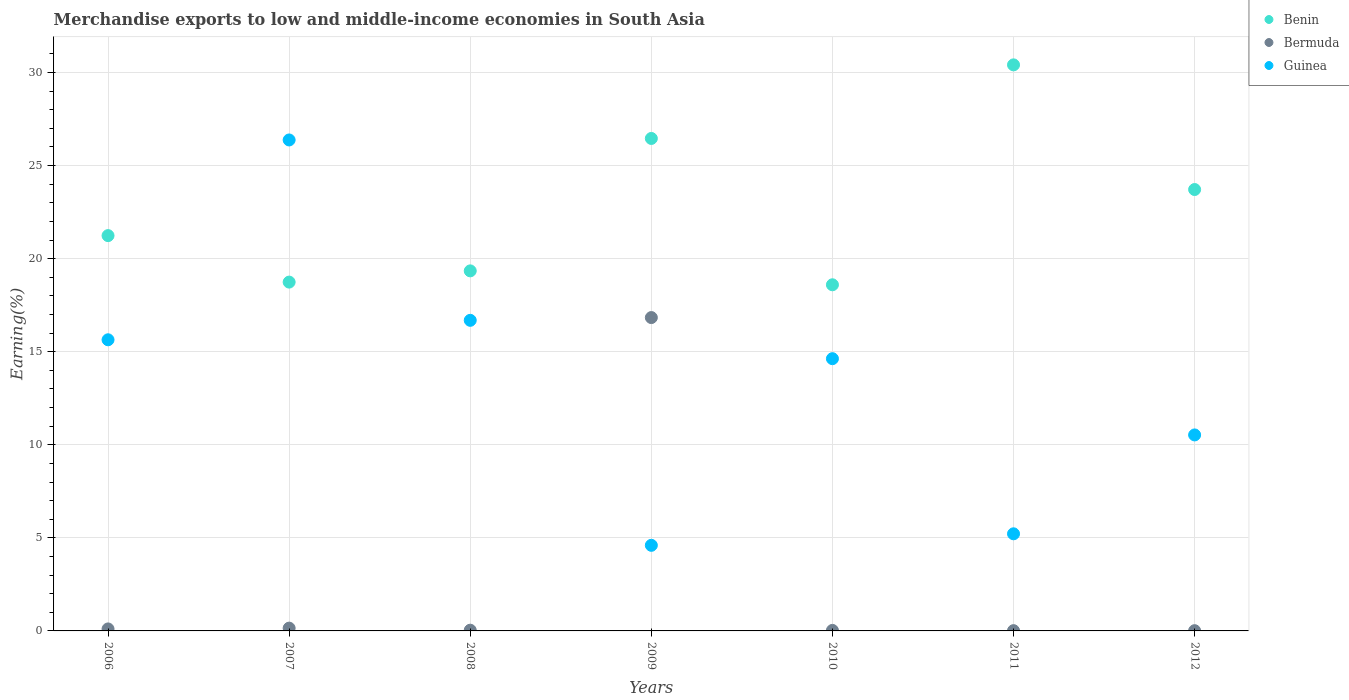Is the number of dotlines equal to the number of legend labels?
Provide a succinct answer. Yes. What is the percentage of amount earned from merchandise exports in Bermuda in 2008?
Offer a terse response. 0.04. Across all years, what is the maximum percentage of amount earned from merchandise exports in Guinea?
Make the answer very short. 26.37. Across all years, what is the minimum percentage of amount earned from merchandise exports in Bermuda?
Provide a succinct answer. 0.01. In which year was the percentage of amount earned from merchandise exports in Guinea maximum?
Provide a succinct answer. 2007. In which year was the percentage of amount earned from merchandise exports in Bermuda minimum?
Your response must be concise. 2012. What is the total percentage of amount earned from merchandise exports in Bermuda in the graph?
Ensure brevity in your answer.  17.18. What is the difference between the percentage of amount earned from merchandise exports in Bermuda in 2006 and that in 2009?
Keep it short and to the point. -16.73. What is the difference between the percentage of amount earned from merchandise exports in Bermuda in 2012 and the percentage of amount earned from merchandise exports in Guinea in 2010?
Ensure brevity in your answer.  -14.61. What is the average percentage of amount earned from merchandise exports in Guinea per year?
Your answer should be compact. 13.38. In the year 2012, what is the difference between the percentage of amount earned from merchandise exports in Guinea and percentage of amount earned from merchandise exports in Benin?
Keep it short and to the point. -13.18. What is the ratio of the percentage of amount earned from merchandise exports in Benin in 2008 to that in 2011?
Ensure brevity in your answer.  0.64. Is the difference between the percentage of amount earned from merchandise exports in Guinea in 2006 and 2007 greater than the difference between the percentage of amount earned from merchandise exports in Benin in 2006 and 2007?
Offer a very short reply. No. What is the difference between the highest and the second highest percentage of amount earned from merchandise exports in Benin?
Your response must be concise. 3.95. What is the difference between the highest and the lowest percentage of amount earned from merchandise exports in Bermuda?
Offer a terse response. 16.82. In how many years, is the percentage of amount earned from merchandise exports in Bermuda greater than the average percentage of amount earned from merchandise exports in Bermuda taken over all years?
Your answer should be compact. 1. Is the sum of the percentage of amount earned from merchandise exports in Benin in 2009 and 2012 greater than the maximum percentage of amount earned from merchandise exports in Guinea across all years?
Offer a very short reply. Yes. Is the percentage of amount earned from merchandise exports in Benin strictly less than the percentage of amount earned from merchandise exports in Bermuda over the years?
Keep it short and to the point. No. How many years are there in the graph?
Offer a terse response. 7. What is the difference between two consecutive major ticks on the Y-axis?
Offer a terse response. 5. Does the graph contain any zero values?
Your response must be concise. No. What is the title of the graph?
Ensure brevity in your answer.  Merchandise exports to low and middle-income economies in South Asia. What is the label or title of the X-axis?
Ensure brevity in your answer.  Years. What is the label or title of the Y-axis?
Your answer should be compact. Earning(%). What is the Earning(%) in Benin in 2006?
Keep it short and to the point. 21.24. What is the Earning(%) in Bermuda in 2006?
Provide a short and direct response. 0.11. What is the Earning(%) in Guinea in 2006?
Ensure brevity in your answer.  15.64. What is the Earning(%) in Benin in 2007?
Ensure brevity in your answer.  18.74. What is the Earning(%) in Bermuda in 2007?
Your answer should be compact. 0.15. What is the Earning(%) of Guinea in 2007?
Give a very brief answer. 26.37. What is the Earning(%) of Benin in 2008?
Offer a very short reply. 19.34. What is the Earning(%) in Bermuda in 2008?
Make the answer very short. 0.04. What is the Earning(%) of Guinea in 2008?
Your answer should be very brief. 16.69. What is the Earning(%) in Benin in 2009?
Provide a short and direct response. 26.46. What is the Earning(%) of Bermuda in 2009?
Your response must be concise. 16.83. What is the Earning(%) of Guinea in 2009?
Provide a succinct answer. 4.6. What is the Earning(%) in Benin in 2010?
Give a very brief answer. 18.59. What is the Earning(%) in Bermuda in 2010?
Provide a short and direct response. 0.03. What is the Earning(%) of Guinea in 2010?
Make the answer very short. 14.62. What is the Earning(%) in Benin in 2011?
Keep it short and to the point. 30.41. What is the Earning(%) of Bermuda in 2011?
Make the answer very short. 0.01. What is the Earning(%) in Guinea in 2011?
Make the answer very short. 5.22. What is the Earning(%) of Benin in 2012?
Keep it short and to the point. 23.71. What is the Earning(%) of Bermuda in 2012?
Your answer should be very brief. 0.01. What is the Earning(%) in Guinea in 2012?
Keep it short and to the point. 10.53. Across all years, what is the maximum Earning(%) of Benin?
Make the answer very short. 30.41. Across all years, what is the maximum Earning(%) of Bermuda?
Your answer should be compact. 16.83. Across all years, what is the maximum Earning(%) of Guinea?
Provide a short and direct response. 26.37. Across all years, what is the minimum Earning(%) in Benin?
Provide a succinct answer. 18.59. Across all years, what is the minimum Earning(%) in Bermuda?
Your answer should be compact. 0.01. Across all years, what is the minimum Earning(%) of Guinea?
Your answer should be compact. 4.6. What is the total Earning(%) of Benin in the graph?
Give a very brief answer. 158.49. What is the total Earning(%) in Bermuda in the graph?
Your answer should be compact. 17.18. What is the total Earning(%) in Guinea in the graph?
Keep it short and to the point. 93.67. What is the difference between the Earning(%) of Benin in 2006 and that in 2007?
Provide a short and direct response. 2.5. What is the difference between the Earning(%) of Bermuda in 2006 and that in 2007?
Your answer should be compact. -0.04. What is the difference between the Earning(%) of Guinea in 2006 and that in 2007?
Give a very brief answer. -10.73. What is the difference between the Earning(%) of Benin in 2006 and that in 2008?
Ensure brevity in your answer.  1.89. What is the difference between the Earning(%) in Bermuda in 2006 and that in 2008?
Ensure brevity in your answer.  0.07. What is the difference between the Earning(%) of Guinea in 2006 and that in 2008?
Your answer should be very brief. -1.05. What is the difference between the Earning(%) in Benin in 2006 and that in 2009?
Your response must be concise. -5.22. What is the difference between the Earning(%) in Bermuda in 2006 and that in 2009?
Offer a very short reply. -16.73. What is the difference between the Earning(%) in Guinea in 2006 and that in 2009?
Make the answer very short. 11.04. What is the difference between the Earning(%) of Benin in 2006 and that in 2010?
Provide a short and direct response. 2.64. What is the difference between the Earning(%) in Bermuda in 2006 and that in 2010?
Offer a very short reply. 0.08. What is the difference between the Earning(%) of Benin in 2006 and that in 2011?
Provide a succinct answer. -9.17. What is the difference between the Earning(%) in Bermuda in 2006 and that in 2011?
Provide a short and direct response. 0.09. What is the difference between the Earning(%) in Guinea in 2006 and that in 2011?
Offer a very short reply. 10.42. What is the difference between the Earning(%) in Benin in 2006 and that in 2012?
Your answer should be compact. -2.48. What is the difference between the Earning(%) of Bermuda in 2006 and that in 2012?
Your answer should be compact. 0.09. What is the difference between the Earning(%) of Guinea in 2006 and that in 2012?
Ensure brevity in your answer.  5.11. What is the difference between the Earning(%) in Benin in 2007 and that in 2008?
Your answer should be very brief. -0.6. What is the difference between the Earning(%) in Bermuda in 2007 and that in 2008?
Offer a very short reply. 0.11. What is the difference between the Earning(%) in Guinea in 2007 and that in 2008?
Offer a very short reply. 9.69. What is the difference between the Earning(%) in Benin in 2007 and that in 2009?
Offer a very short reply. -7.72. What is the difference between the Earning(%) of Bermuda in 2007 and that in 2009?
Provide a succinct answer. -16.68. What is the difference between the Earning(%) in Guinea in 2007 and that in 2009?
Provide a succinct answer. 21.78. What is the difference between the Earning(%) of Benin in 2007 and that in 2010?
Keep it short and to the point. 0.14. What is the difference between the Earning(%) of Bermuda in 2007 and that in 2010?
Offer a very short reply. 0.12. What is the difference between the Earning(%) in Guinea in 2007 and that in 2010?
Give a very brief answer. 11.75. What is the difference between the Earning(%) of Benin in 2007 and that in 2011?
Make the answer very short. -11.67. What is the difference between the Earning(%) in Bermuda in 2007 and that in 2011?
Give a very brief answer. 0.14. What is the difference between the Earning(%) of Guinea in 2007 and that in 2011?
Give a very brief answer. 21.16. What is the difference between the Earning(%) in Benin in 2007 and that in 2012?
Ensure brevity in your answer.  -4.97. What is the difference between the Earning(%) in Bermuda in 2007 and that in 2012?
Offer a very short reply. 0.14. What is the difference between the Earning(%) of Guinea in 2007 and that in 2012?
Give a very brief answer. 15.85. What is the difference between the Earning(%) in Benin in 2008 and that in 2009?
Provide a succinct answer. -7.11. What is the difference between the Earning(%) of Bermuda in 2008 and that in 2009?
Give a very brief answer. -16.79. What is the difference between the Earning(%) in Guinea in 2008 and that in 2009?
Offer a terse response. 12.09. What is the difference between the Earning(%) in Benin in 2008 and that in 2010?
Ensure brevity in your answer.  0.75. What is the difference between the Earning(%) in Bermuda in 2008 and that in 2010?
Offer a terse response. 0.01. What is the difference between the Earning(%) in Guinea in 2008 and that in 2010?
Make the answer very short. 2.06. What is the difference between the Earning(%) in Benin in 2008 and that in 2011?
Make the answer very short. -11.07. What is the difference between the Earning(%) in Bermuda in 2008 and that in 2011?
Provide a short and direct response. 0.02. What is the difference between the Earning(%) of Guinea in 2008 and that in 2011?
Your answer should be very brief. 11.47. What is the difference between the Earning(%) of Benin in 2008 and that in 2012?
Make the answer very short. -4.37. What is the difference between the Earning(%) of Bermuda in 2008 and that in 2012?
Your answer should be compact. 0.03. What is the difference between the Earning(%) of Guinea in 2008 and that in 2012?
Provide a succinct answer. 6.16. What is the difference between the Earning(%) in Benin in 2009 and that in 2010?
Your response must be concise. 7.86. What is the difference between the Earning(%) of Bermuda in 2009 and that in 2010?
Give a very brief answer. 16.81. What is the difference between the Earning(%) of Guinea in 2009 and that in 2010?
Your answer should be very brief. -10.03. What is the difference between the Earning(%) of Benin in 2009 and that in 2011?
Ensure brevity in your answer.  -3.95. What is the difference between the Earning(%) of Bermuda in 2009 and that in 2011?
Give a very brief answer. 16.82. What is the difference between the Earning(%) in Guinea in 2009 and that in 2011?
Provide a succinct answer. -0.62. What is the difference between the Earning(%) in Benin in 2009 and that in 2012?
Keep it short and to the point. 2.74. What is the difference between the Earning(%) in Bermuda in 2009 and that in 2012?
Make the answer very short. 16.82. What is the difference between the Earning(%) in Guinea in 2009 and that in 2012?
Provide a short and direct response. -5.93. What is the difference between the Earning(%) in Benin in 2010 and that in 2011?
Offer a very short reply. -11.81. What is the difference between the Earning(%) in Bermuda in 2010 and that in 2011?
Make the answer very short. 0.01. What is the difference between the Earning(%) in Guinea in 2010 and that in 2011?
Ensure brevity in your answer.  9.41. What is the difference between the Earning(%) in Benin in 2010 and that in 2012?
Offer a very short reply. -5.12. What is the difference between the Earning(%) in Bermuda in 2010 and that in 2012?
Make the answer very short. 0.01. What is the difference between the Earning(%) in Guinea in 2010 and that in 2012?
Ensure brevity in your answer.  4.1. What is the difference between the Earning(%) of Benin in 2011 and that in 2012?
Give a very brief answer. 6.7. What is the difference between the Earning(%) of Bermuda in 2011 and that in 2012?
Provide a short and direct response. 0. What is the difference between the Earning(%) in Guinea in 2011 and that in 2012?
Keep it short and to the point. -5.31. What is the difference between the Earning(%) of Benin in 2006 and the Earning(%) of Bermuda in 2007?
Your answer should be compact. 21.09. What is the difference between the Earning(%) of Benin in 2006 and the Earning(%) of Guinea in 2007?
Keep it short and to the point. -5.14. What is the difference between the Earning(%) of Bermuda in 2006 and the Earning(%) of Guinea in 2007?
Offer a terse response. -26.27. What is the difference between the Earning(%) in Benin in 2006 and the Earning(%) in Bermuda in 2008?
Offer a terse response. 21.2. What is the difference between the Earning(%) of Benin in 2006 and the Earning(%) of Guinea in 2008?
Offer a terse response. 4.55. What is the difference between the Earning(%) of Bermuda in 2006 and the Earning(%) of Guinea in 2008?
Provide a short and direct response. -16.58. What is the difference between the Earning(%) of Benin in 2006 and the Earning(%) of Bermuda in 2009?
Keep it short and to the point. 4.4. What is the difference between the Earning(%) in Benin in 2006 and the Earning(%) in Guinea in 2009?
Your answer should be very brief. 16.64. What is the difference between the Earning(%) of Bermuda in 2006 and the Earning(%) of Guinea in 2009?
Provide a succinct answer. -4.49. What is the difference between the Earning(%) in Benin in 2006 and the Earning(%) in Bermuda in 2010?
Keep it short and to the point. 21.21. What is the difference between the Earning(%) of Benin in 2006 and the Earning(%) of Guinea in 2010?
Your answer should be compact. 6.61. What is the difference between the Earning(%) in Bermuda in 2006 and the Earning(%) in Guinea in 2010?
Ensure brevity in your answer.  -14.52. What is the difference between the Earning(%) in Benin in 2006 and the Earning(%) in Bermuda in 2011?
Your response must be concise. 21.22. What is the difference between the Earning(%) of Benin in 2006 and the Earning(%) of Guinea in 2011?
Ensure brevity in your answer.  16.02. What is the difference between the Earning(%) of Bermuda in 2006 and the Earning(%) of Guinea in 2011?
Offer a very short reply. -5.11. What is the difference between the Earning(%) in Benin in 2006 and the Earning(%) in Bermuda in 2012?
Your answer should be very brief. 21.22. What is the difference between the Earning(%) of Benin in 2006 and the Earning(%) of Guinea in 2012?
Provide a succinct answer. 10.71. What is the difference between the Earning(%) in Bermuda in 2006 and the Earning(%) in Guinea in 2012?
Provide a short and direct response. -10.42. What is the difference between the Earning(%) in Benin in 2007 and the Earning(%) in Guinea in 2008?
Keep it short and to the point. 2.05. What is the difference between the Earning(%) in Bermuda in 2007 and the Earning(%) in Guinea in 2008?
Ensure brevity in your answer.  -16.54. What is the difference between the Earning(%) of Benin in 2007 and the Earning(%) of Bermuda in 2009?
Give a very brief answer. 1.91. What is the difference between the Earning(%) in Benin in 2007 and the Earning(%) in Guinea in 2009?
Give a very brief answer. 14.14. What is the difference between the Earning(%) of Bermuda in 2007 and the Earning(%) of Guinea in 2009?
Ensure brevity in your answer.  -4.45. What is the difference between the Earning(%) of Benin in 2007 and the Earning(%) of Bermuda in 2010?
Offer a terse response. 18.71. What is the difference between the Earning(%) in Benin in 2007 and the Earning(%) in Guinea in 2010?
Ensure brevity in your answer.  4.11. What is the difference between the Earning(%) of Bermuda in 2007 and the Earning(%) of Guinea in 2010?
Provide a succinct answer. -14.48. What is the difference between the Earning(%) of Benin in 2007 and the Earning(%) of Bermuda in 2011?
Provide a succinct answer. 18.72. What is the difference between the Earning(%) of Benin in 2007 and the Earning(%) of Guinea in 2011?
Give a very brief answer. 13.52. What is the difference between the Earning(%) in Bermuda in 2007 and the Earning(%) in Guinea in 2011?
Your answer should be compact. -5.07. What is the difference between the Earning(%) of Benin in 2007 and the Earning(%) of Bermuda in 2012?
Offer a terse response. 18.73. What is the difference between the Earning(%) of Benin in 2007 and the Earning(%) of Guinea in 2012?
Your answer should be compact. 8.21. What is the difference between the Earning(%) of Bermuda in 2007 and the Earning(%) of Guinea in 2012?
Your answer should be very brief. -10.38. What is the difference between the Earning(%) of Benin in 2008 and the Earning(%) of Bermuda in 2009?
Make the answer very short. 2.51. What is the difference between the Earning(%) in Benin in 2008 and the Earning(%) in Guinea in 2009?
Your answer should be very brief. 14.74. What is the difference between the Earning(%) of Bermuda in 2008 and the Earning(%) of Guinea in 2009?
Provide a short and direct response. -4.56. What is the difference between the Earning(%) of Benin in 2008 and the Earning(%) of Bermuda in 2010?
Make the answer very short. 19.31. What is the difference between the Earning(%) of Benin in 2008 and the Earning(%) of Guinea in 2010?
Your answer should be very brief. 4.72. What is the difference between the Earning(%) in Bermuda in 2008 and the Earning(%) in Guinea in 2010?
Offer a very short reply. -14.59. What is the difference between the Earning(%) in Benin in 2008 and the Earning(%) in Bermuda in 2011?
Your response must be concise. 19.33. What is the difference between the Earning(%) in Benin in 2008 and the Earning(%) in Guinea in 2011?
Make the answer very short. 14.12. What is the difference between the Earning(%) in Bermuda in 2008 and the Earning(%) in Guinea in 2011?
Provide a succinct answer. -5.18. What is the difference between the Earning(%) of Benin in 2008 and the Earning(%) of Bermuda in 2012?
Your answer should be compact. 19.33. What is the difference between the Earning(%) in Benin in 2008 and the Earning(%) in Guinea in 2012?
Offer a very short reply. 8.81. What is the difference between the Earning(%) of Bermuda in 2008 and the Earning(%) of Guinea in 2012?
Your response must be concise. -10.49. What is the difference between the Earning(%) of Benin in 2009 and the Earning(%) of Bermuda in 2010?
Provide a succinct answer. 26.43. What is the difference between the Earning(%) of Benin in 2009 and the Earning(%) of Guinea in 2010?
Make the answer very short. 11.83. What is the difference between the Earning(%) of Bermuda in 2009 and the Earning(%) of Guinea in 2010?
Your response must be concise. 2.21. What is the difference between the Earning(%) in Benin in 2009 and the Earning(%) in Bermuda in 2011?
Your answer should be compact. 26.44. What is the difference between the Earning(%) in Benin in 2009 and the Earning(%) in Guinea in 2011?
Provide a succinct answer. 21.24. What is the difference between the Earning(%) in Bermuda in 2009 and the Earning(%) in Guinea in 2011?
Give a very brief answer. 11.62. What is the difference between the Earning(%) of Benin in 2009 and the Earning(%) of Bermuda in 2012?
Your response must be concise. 26.44. What is the difference between the Earning(%) of Benin in 2009 and the Earning(%) of Guinea in 2012?
Offer a terse response. 15.93. What is the difference between the Earning(%) in Bermuda in 2009 and the Earning(%) in Guinea in 2012?
Give a very brief answer. 6.3. What is the difference between the Earning(%) in Benin in 2010 and the Earning(%) in Bermuda in 2011?
Offer a terse response. 18.58. What is the difference between the Earning(%) in Benin in 2010 and the Earning(%) in Guinea in 2011?
Give a very brief answer. 13.38. What is the difference between the Earning(%) of Bermuda in 2010 and the Earning(%) of Guinea in 2011?
Offer a very short reply. -5.19. What is the difference between the Earning(%) in Benin in 2010 and the Earning(%) in Bermuda in 2012?
Provide a succinct answer. 18.58. What is the difference between the Earning(%) of Benin in 2010 and the Earning(%) of Guinea in 2012?
Offer a terse response. 8.07. What is the difference between the Earning(%) in Bermuda in 2010 and the Earning(%) in Guinea in 2012?
Ensure brevity in your answer.  -10.5. What is the difference between the Earning(%) in Benin in 2011 and the Earning(%) in Bermuda in 2012?
Your answer should be very brief. 30.4. What is the difference between the Earning(%) in Benin in 2011 and the Earning(%) in Guinea in 2012?
Your response must be concise. 19.88. What is the difference between the Earning(%) of Bermuda in 2011 and the Earning(%) of Guinea in 2012?
Keep it short and to the point. -10.51. What is the average Earning(%) in Benin per year?
Your response must be concise. 22.64. What is the average Earning(%) of Bermuda per year?
Provide a succinct answer. 2.46. What is the average Earning(%) in Guinea per year?
Provide a succinct answer. 13.38. In the year 2006, what is the difference between the Earning(%) of Benin and Earning(%) of Bermuda?
Ensure brevity in your answer.  21.13. In the year 2006, what is the difference between the Earning(%) of Benin and Earning(%) of Guinea?
Provide a succinct answer. 5.6. In the year 2006, what is the difference between the Earning(%) of Bermuda and Earning(%) of Guinea?
Provide a short and direct response. -15.53. In the year 2007, what is the difference between the Earning(%) in Benin and Earning(%) in Bermuda?
Offer a very short reply. 18.59. In the year 2007, what is the difference between the Earning(%) in Benin and Earning(%) in Guinea?
Make the answer very short. -7.64. In the year 2007, what is the difference between the Earning(%) of Bermuda and Earning(%) of Guinea?
Keep it short and to the point. -26.22. In the year 2008, what is the difference between the Earning(%) of Benin and Earning(%) of Bermuda?
Your response must be concise. 19.3. In the year 2008, what is the difference between the Earning(%) of Benin and Earning(%) of Guinea?
Offer a terse response. 2.66. In the year 2008, what is the difference between the Earning(%) of Bermuda and Earning(%) of Guinea?
Give a very brief answer. -16.65. In the year 2009, what is the difference between the Earning(%) in Benin and Earning(%) in Bermuda?
Provide a short and direct response. 9.62. In the year 2009, what is the difference between the Earning(%) in Benin and Earning(%) in Guinea?
Offer a very short reply. 21.86. In the year 2009, what is the difference between the Earning(%) of Bermuda and Earning(%) of Guinea?
Provide a short and direct response. 12.23. In the year 2010, what is the difference between the Earning(%) of Benin and Earning(%) of Bermuda?
Your response must be concise. 18.57. In the year 2010, what is the difference between the Earning(%) of Benin and Earning(%) of Guinea?
Offer a very short reply. 3.97. In the year 2010, what is the difference between the Earning(%) of Bermuda and Earning(%) of Guinea?
Offer a very short reply. -14.6. In the year 2011, what is the difference between the Earning(%) of Benin and Earning(%) of Bermuda?
Keep it short and to the point. 30.39. In the year 2011, what is the difference between the Earning(%) of Benin and Earning(%) of Guinea?
Offer a terse response. 25.19. In the year 2011, what is the difference between the Earning(%) of Bermuda and Earning(%) of Guinea?
Ensure brevity in your answer.  -5.2. In the year 2012, what is the difference between the Earning(%) of Benin and Earning(%) of Bermuda?
Provide a succinct answer. 23.7. In the year 2012, what is the difference between the Earning(%) of Benin and Earning(%) of Guinea?
Offer a terse response. 13.18. In the year 2012, what is the difference between the Earning(%) in Bermuda and Earning(%) in Guinea?
Provide a succinct answer. -10.52. What is the ratio of the Earning(%) in Benin in 2006 to that in 2007?
Your response must be concise. 1.13. What is the ratio of the Earning(%) of Bermuda in 2006 to that in 2007?
Provide a succinct answer. 0.72. What is the ratio of the Earning(%) in Guinea in 2006 to that in 2007?
Provide a succinct answer. 0.59. What is the ratio of the Earning(%) in Benin in 2006 to that in 2008?
Your response must be concise. 1.1. What is the ratio of the Earning(%) of Bermuda in 2006 to that in 2008?
Keep it short and to the point. 2.76. What is the ratio of the Earning(%) in Guinea in 2006 to that in 2008?
Give a very brief answer. 0.94. What is the ratio of the Earning(%) of Benin in 2006 to that in 2009?
Offer a terse response. 0.8. What is the ratio of the Earning(%) of Bermuda in 2006 to that in 2009?
Your answer should be compact. 0.01. What is the ratio of the Earning(%) in Guinea in 2006 to that in 2009?
Give a very brief answer. 3.4. What is the ratio of the Earning(%) of Benin in 2006 to that in 2010?
Your response must be concise. 1.14. What is the ratio of the Earning(%) in Bermuda in 2006 to that in 2010?
Your response must be concise. 3.81. What is the ratio of the Earning(%) in Guinea in 2006 to that in 2010?
Your answer should be compact. 1.07. What is the ratio of the Earning(%) in Benin in 2006 to that in 2011?
Offer a very short reply. 0.7. What is the ratio of the Earning(%) of Bermuda in 2006 to that in 2011?
Your response must be concise. 7.46. What is the ratio of the Earning(%) of Guinea in 2006 to that in 2011?
Provide a short and direct response. 3. What is the ratio of the Earning(%) in Benin in 2006 to that in 2012?
Make the answer very short. 0.9. What is the ratio of the Earning(%) in Bermuda in 2006 to that in 2012?
Offer a terse response. 8.07. What is the ratio of the Earning(%) of Guinea in 2006 to that in 2012?
Give a very brief answer. 1.49. What is the ratio of the Earning(%) of Benin in 2007 to that in 2008?
Offer a terse response. 0.97. What is the ratio of the Earning(%) in Bermuda in 2007 to that in 2008?
Your answer should be compact. 3.85. What is the ratio of the Earning(%) in Guinea in 2007 to that in 2008?
Offer a very short reply. 1.58. What is the ratio of the Earning(%) in Benin in 2007 to that in 2009?
Make the answer very short. 0.71. What is the ratio of the Earning(%) of Bermuda in 2007 to that in 2009?
Offer a very short reply. 0.01. What is the ratio of the Earning(%) in Guinea in 2007 to that in 2009?
Provide a succinct answer. 5.74. What is the ratio of the Earning(%) of Benin in 2007 to that in 2010?
Ensure brevity in your answer.  1.01. What is the ratio of the Earning(%) in Bermuda in 2007 to that in 2010?
Offer a very short reply. 5.32. What is the ratio of the Earning(%) in Guinea in 2007 to that in 2010?
Provide a succinct answer. 1.8. What is the ratio of the Earning(%) of Benin in 2007 to that in 2011?
Ensure brevity in your answer.  0.62. What is the ratio of the Earning(%) of Bermuda in 2007 to that in 2011?
Give a very brief answer. 10.42. What is the ratio of the Earning(%) of Guinea in 2007 to that in 2011?
Provide a short and direct response. 5.06. What is the ratio of the Earning(%) in Benin in 2007 to that in 2012?
Offer a terse response. 0.79. What is the ratio of the Earning(%) of Bermuda in 2007 to that in 2012?
Give a very brief answer. 11.27. What is the ratio of the Earning(%) of Guinea in 2007 to that in 2012?
Ensure brevity in your answer.  2.5. What is the ratio of the Earning(%) of Benin in 2008 to that in 2009?
Your response must be concise. 0.73. What is the ratio of the Earning(%) of Bermuda in 2008 to that in 2009?
Your answer should be very brief. 0. What is the ratio of the Earning(%) in Guinea in 2008 to that in 2009?
Ensure brevity in your answer.  3.63. What is the ratio of the Earning(%) in Benin in 2008 to that in 2010?
Provide a short and direct response. 1.04. What is the ratio of the Earning(%) of Bermuda in 2008 to that in 2010?
Provide a succinct answer. 1.38. What is the ratio of the Earning(%) of Guinea in 2008 to that in 2010?
Keep it short and to the point. 1.14. What is the ratio of the Earning(%) of Benin in 2008 to that in 2011?
Make the answer very short. 0.64. What is the ratio of the Earning(%) of Bermuda in 2008 to that in 2011?
Offer a very short reply. 2.7. What is the ratio of the Earning(%) in Guinea in 2008 to that in 2011?
Your response must be concise. 3.2. What is the ratio of the Earning(%) in Benin in 2008 to that in 2012?
Your answer should be very brief. 0.82. What is the ratio of the Earning(%) of Bermuda in 2008 to that in 2012?
Your answer should be compact. 2.92. What is the ratio of the Earning(%) in Guinea in 2008 to that in 2012?
Your answer should be compact. 1.58. What is the ratio of the Earning(%) in Benin in 2009 to that in 2010?
Provide a succinct answer. 1.42. What is the ratio of the Earning(%) in Bermuda in 2009 to that in 2010?
Ensure brevity in your answer.  598.28. What is the ratio of the Earning(%) of Guinea in 2009 to that in 2010?
Your answer should be compact. 0.31. What is the ratio of the Earning(%) in Benin in 2009 to that in 2011?
Your answer should be very brief. 0.87. What is the ratio of the Earning(%) in Bermuda in 2009 to that in 2011?
Make the answer very short. 1171.5. What is the ratio of the Earning(%) of Guinea in 2009 to that in 2011?
Ensure brevity in your answer.  0.88. What is the ratio of the Earning(%) in Benin in 2009 to that in 2012?
Offer a very short reply. 1.12. What is the ratio of the Earning(%) of Bermuda in 2009 to that in 2012?
Your answer should be very brief. 1266.96. What is the ratio of the Earning(%) of Guinea in 2009 to that in 2012?
Keep it short and to the point. 0.44. What is the ratio of the Earning(%) in Benin in 2010 to that in 2011?
Provide a short and direct response. 0.61. What is the ratio of the Earning(%) in Bermuda in 2010 to that in 2011?
Your answer should be compact. 1.96. What is the ratio of the Earning(%) of Guinea in 2010 to that in 2011?
Make the answer very short. 2.8. What is the ratio of the Earning(%) in Benin in 2010 to that in 2012?
Your response must be concise. 0.78. What is the ratio of the Earning(%) of Bermuda in 2010 to that in 2012?
Make the answer very short. 2.12. What is the ratio of the Earning(%) of Guinea in 2010 to that in 2012?
Offer a terse response. 1.39. What is the ratio of the Earning(%) of Benin in 2011 to that in 2012?
Make the answer very short. 1.28. What is the ratio of the Earning(%) in Bermuda in 2011 to that in 2012?
Your answer should be very brief. 1.08. What is the ratio of the Earning(%) in Guinea in 2011 to that in 2012?
Your answer should be compact. 0.5. What is the difference between the highest and the second highest Earning(%) in Benin?
Provide a short and direct response. 3.95. What is the difference between the highest and the second highest Earning(%) of Bermuda?
Provide a short and direct response. 16.68. What is the difference between the highest and the second highest Earning(%) in Guinea?
Keep it short and to the point. 9.69. What is the difference between the highest and the lowest Earning(%) in Benin?
Provide a succinct answer. 11.81. What is the difference between the highest and the lowest Earning(%) in Bermuda?
Offer a very short reply. 16.82. What is the difference between the highest and the lowest Earning(%) of Guinea?
Provide a succinct answer. 21.78. 